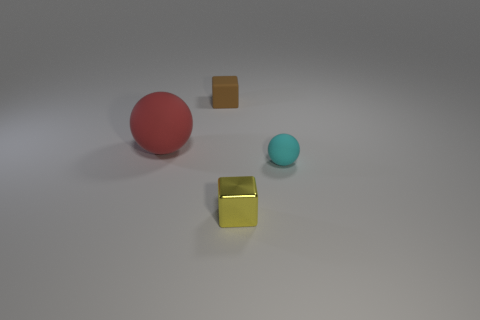Is there any indication of the light source in the image? The light source in the image is not directly visible. However, we can infer that there is a light source based on the shadows and reflections. Each object casts a shadow away from the foreground toward the background, suggesting that the light source is in front of the objects, likely above them. 